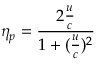Convert formula to latex. <formula><loc_0><loc_0><loc_500><loc_500>\eta _ { p } = { \frac { 2 { \frac { u } { c } } } { 1 + ( { \frac { u } { c } } ) ^ { 2 } } }</formula> 